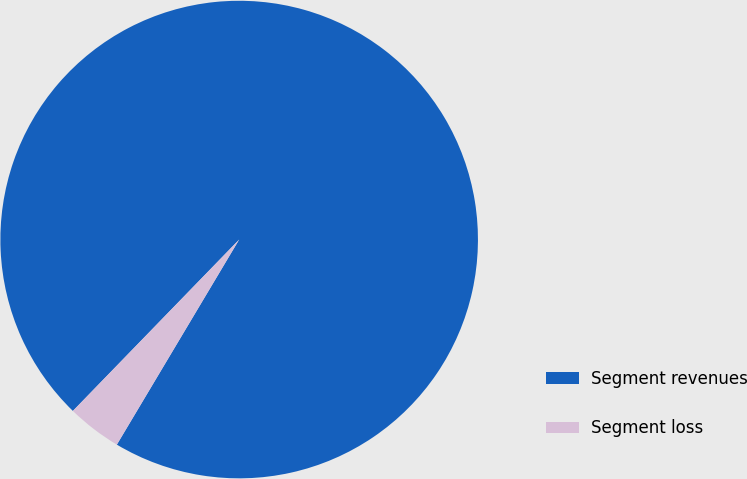<chart> <loc_0><loc_0><loc_500><loc_500><pie_chart><fcel>Segment revenues<fcel>Segment loss<nl><fcel>96.3%<fcel>3.7%<nl></chart> 